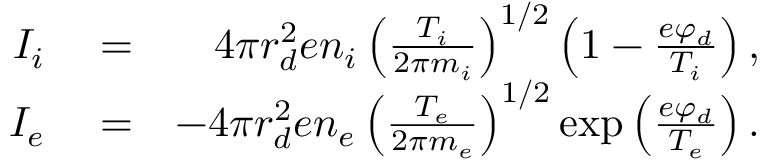Convert formula to latex. <formula><loc_0><loc_0><loc_500><loc_500>\begin{array} { r l r } { I _ { i } } & = } & { 4 \pi r _ { d } ^ { 2 } e n _ { i } \left ( \frac { T _ { i } } { 2 \pi m _ { i } } \right ) ^ { 1 / 2 } \left ( 1 - \frac { e \varphi _ { d } } { T _ { i } } \right ) , } \\ { I _ { e } } & = } & { - 4 \pi r _ { d } ^ { 2 } e n _ { e } \left ( \frac { T _ { e } } { 2 \pi m _ { e } } \right ) ^ { 1 / 2 } \exp \left ( \frac { e \varphi _ { d } } { T _ { e } } \right ) . } \end{array}</formula> 